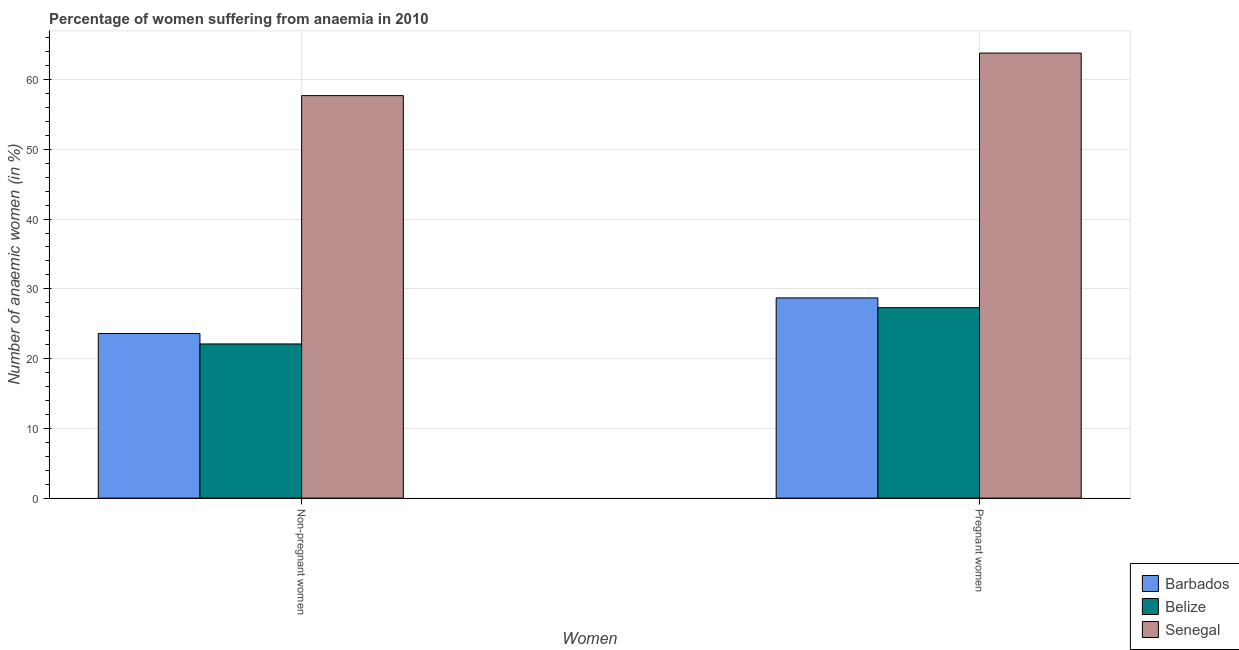How many different coloured bars are there?
Make the answer very short. 3. How many groups of bars are there?
Offer a terse response. 2. Are the number of bars on each tick of the X-axis equal?
Your response must be concise. Yes. How many bars are there on the 2nd tick from the right?
Your response must be concise. 3. What is the label of the 1st group of bars from the left?
Offer a very short reply. Non-pregnant women. What is the percentage of pregnant anaemic women in Senegal?
Ensure brevity in your answer.  63.8. Across all countries, what is the maximum percentage of pregnant anaemic women?
Give a very brief answer. 63.8. Across all countries, what is the minimum percentage of pregnant anaemic women?
Your answer should be compact. 27.3. In which country was the percentage of pregnant anaemic women maximum?
Your response must be concise. Senegal. In which country was the percentage of pregnant anaemic women minimum?
Make the answer very short. Belize. What is the total percentage of non-pregnant anaemic women in the graph?
Your answer should be very brief. 103.4. What is the difference between the percentage of non-pregnant anaemic women in Senegal and that in Belize?
Provide a succinct answer. 35.6. What is the difference between the percentage of non-pregnant anaemic women in Senegal and the percentage of pregnant anaemic women in Belize?
Your response must be concise. 30.4. What is the average percentage of pregnant anaemic women per country?
Your answer should be very brief. 39.93. What is the difference between the percentage of pregnant anaemic women and percentage of non-pregnant anaemic women in Barbados?
Provide a short and direct response. 5.1. What is the ratio of the percentage of pregnant anaemic women in Belize to that in Senegal?
Provide a short and direct response. 0.43. What does the 1st bar from the left in Non-pregnant women represents?
Your answer should be very brief. Barbados. What does the 2nd bar from the right in Non-pregnant women represents?
Make the answer very short. Belize. Are all the bars in the graph horizontal?
Offer a terse response. No. Does the graph contain any zero values?
Give a very brief answer. No. Does the graph contain grids?
Your response must be concise. Yes. Where does the legend appear in the graph?
Your response must be concise. Bottom right. How many legend labels are there?
Make the answer very short. 3. How are the legend labels stacked?
Make the answer very short. Vertical. What is the title of the graph?
Provide a succinct answer. Percentage of women suffering from anaemia in 2010. Does "Egypt, Arab Rep." appear as one of the legend labels in the graph?
Keep it short and to the point. No. What is the label or title of the X-axis?
Your answer should be compact. Women. What is the label or title of the Y-axis?
Make the answer very short. Number of anaemic women (in %). What is the Number of anaemic women (in %) in Barbados in Non-pregnant women?
Provide a succinct answer. 23.6. What is the Number of anaemic women (in %) of Belize in Non-pregnant women?
Offer a terse response. 22.1. What is the Number of anaemic women (in %) of Senegal in Non-pregnant women?
Give a very brief answer. 57.7. What is the Number of anaemic women (in %) in Barbados in Pregnant women?
Offer a terse response. 28.7. What is the Number of anaemic women (in %) in Belize in Pregnant women?
Your answer should be very brief. 27.3. What is the Number of anaemic women (in %) in Senegal in Pregnant women?
Keep it short and to the point. 63.8. Across all Women, what is the maximum Number of anaemic women (in %) in Barbados?
Make the answer very short. 28.7. Across all Women, what is the maximum Number of anaemic women (in %) of Belize?
Your response must be concise. 27.3. Across all Women, what is the maximum Number of anaemic women (in %) in Senegal?
Offer a very short reply. 63.8. Across all Women, what is the minimum Number of anaemic women (in %) of Barbados?
Your answer should be compact. 23.6. Across all Women, what is the minimum Number of anaemic women (in %) of Belize?
Give a very brief answer. 22.1. Across all Women, what is the minimum Number of anaemic women (in %) of Senegal?
Give a very brief answer. 57.7. What is the total Number of anaemic women (in %) of Barbados in the graph?
Give a very brief answer. 52.3. What is the total Number of anaemic women (in %) of Belize in the graph?
Provide a succinct answer. 49.4. What is the total Number of anaemic women (in %) in Senegal in the graph?
Give a very brief answer. 121.5. What is the difference between the Number of anaemic women (in %) in Barbados in Non-pregnant women and the Number of anaemic women (in %) in Senegal in Pregnant women?
Make the answer very short. -40.2. What is the difference between the Number of anaemic women (in %) in Belize in Non-pregnant women and the Number of anaemic women (in %) in Senegal in Pregnant women?
Offer a very short reply. -41.7. What is the average Number of anaemic women (in %) of Barbados per Women?
Make the answer very short. 26.15. What is the average Number of anaemic women (in %) in Belize per Women?
Provide a short and direct response. 24.7. What is the average Number of anaemic women (in %) of Senegal per Women?
Your response must be concise. 60.75. What is the difference between the Number of anaemic women (in %) of Barbados and Number of anaemic women (in %) of Senegal in Non-pregnant women?
Your response must be concise. -34.1. What is the difference between the Number of anaemic women (in %) of Belize and Number of anaemic women (in %) of Senegal in Non-pregnant women?
Give a very brief answer. -35.6. What is the difference between the Number of anaemic women (in %) in Barbados and Number of anaemic women (in %) in Senegal in Pregnant women?
Your response must be concise. -35.1. What is the difference between the Number of anaemic women (in %) of Belize and Number of anaemic women (in %) of Senegal in Pregnant women?
Keep it short and to the point. -36.5. What is the ratio of the Number of anaemic women (in %) of Barbados in Non-pregnant women to that in Pregnant women?
Provide a short and direct response. 0.82. What is the ratio of the Number of anaemic women (in %) in Belize in Non-pregnant women to that in Pregnant women?
Your answer should be compact. 0.81. What is the ratio of the Number of anaemic women (in %) of Senegal in Non-pregnant women to that in Pregnant women?
Your answer should be compact. 0.9. What is the difference between the highest and the lowest Number of anaemic women (in %) in Barbados?
Give a very brief answer. 5.1. What is the difference between the highest and the lowest Number of anaemic women (in %) of Belize?
Offer a terse response. 5.2. 